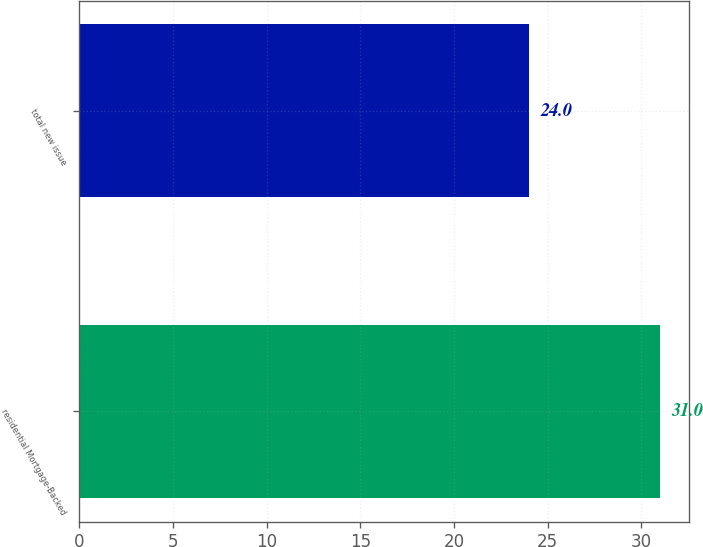<chart> <loc_0><loc_0><loc_500><loc_500><bar_chart><fcel>residential Mortgage-Backed<fcel>total new issue<nl><fcel>31<fcel>24<nl></chart> 